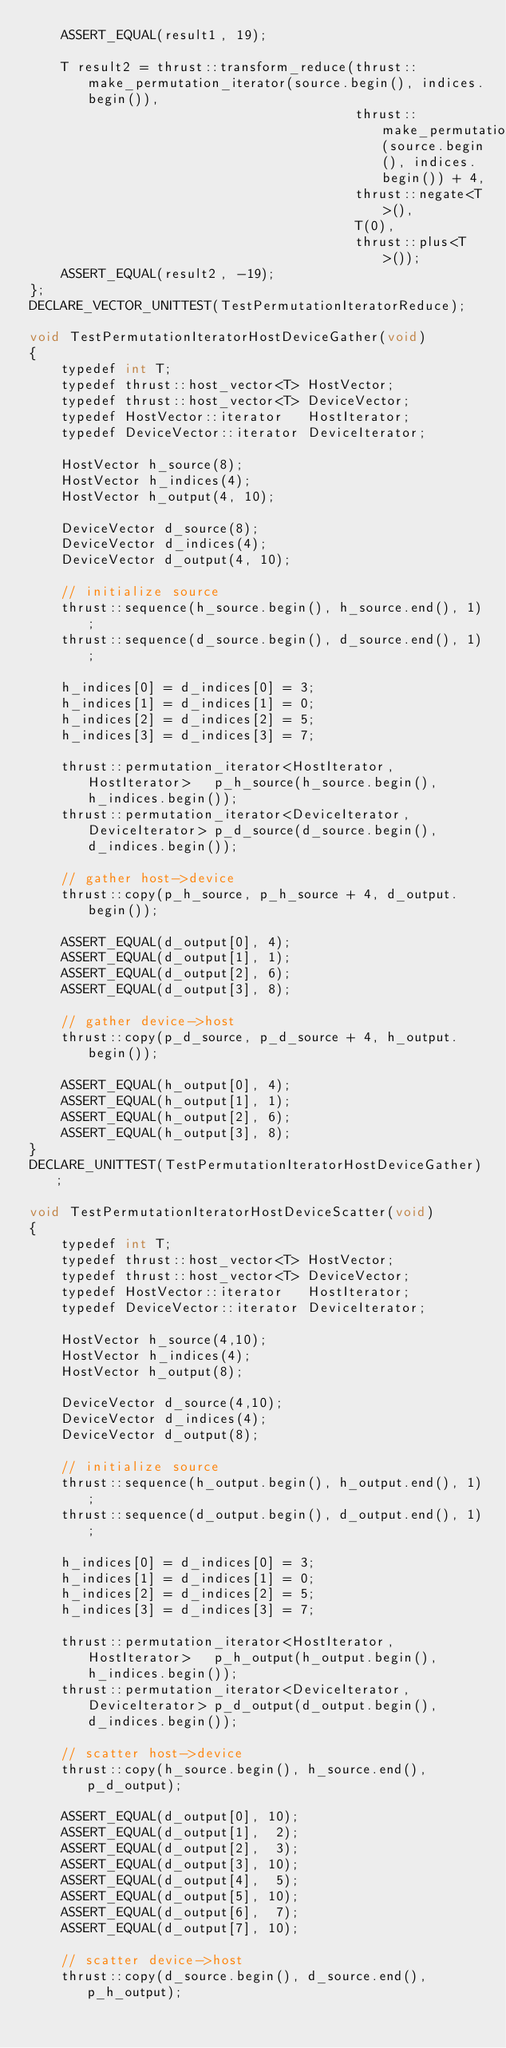Convert code to text. <code><loc_0><loc_0><loc_500><loc_500><_Cuda_>    ASSERT_EQUAL(result1, 19);
    
    T result2 = thrust::transform_reduce(thrust::make_permutation_iterator(source.begin(), indices.begin()),
                                         thrust::make_permutation_iterator(source.begin(), indices.begin()) + 4,
                                         thrust::negate<T>(),
                                         T(0),
                                         thrust::plus<T>());
    ASSERT_EQUAL(result2, -19);
};
DECLARE_VECTOR_UNITTEST(TestPermutationIteratorReduce);

void TestPermutationIteratorHostDeviceGather(void)
{
    typedef int T;
    typedef thrust::host_vector<T> HostVector;
    typedef thrust::host_vector<T> DeviceVector;
    typedef HostVector::iterator   HostIterator;
    typedef DeviceVector::iterator DeviceIterator;

    HostVector h_source(8);
    HostVector h_indices(4);
    HostVector h_output(4, 10);
    
    DeviceVector d_source(8);
    DeviceVector d_indices(4);
    DeviceVector d_output(4, 10);

    // initialize source
    thrust::sequence(h_source.begin(), h_source.end(), 1);
    thrust::sequence(d_source.begin(), d_source.end(), 1);

    h_indices[0] = d_indices[0] = 3;
    h_indices[1] = d_indices[1] = 0;
    h_indices[2] = d_indices[2] = 5;
    h_indices[3] = d_indices[3] = 7;
   
    thrust::permutation_iterator<HostIterator,   HostIterator>   p_h_source(h_source.begin(), h_indices.begin());
    thrust::permutation_iterator<DeviceIterator, DeviceIterator> p_d_source(d_source.begin(), d_indices.begin());

    // gather host->device
    thrust::copy(p_h_source, p_h_source + 4, d_output.begin());

    ASSERT_EQUAL(d_output[0], 4);
    ASSERT_EQUAL(d_output[1], 1);
    ASSERT_EQUAL(d_output[2], 6);
    ASSERT_EQUAL(d_output[3], 8);
    
    // gather device->host
    thrust::copy(p_d_source, p_d_source + 4, h_output.begin());

    ASSERT_EQUAL(h_output[0], 4);
    ASSERT_EQUAL(h_output[1], 1);
    ASSERT_EQUAL(h_output[2], 6);
    ASSERT_EQUAL(h_output[3], 8);
}
DECLARE_UNITTEST(TestPermutationIteratorHostDeviceGather);

void TestPermutationIteratorHostDeviceScatter(void)
{
    typedef int T;
    typedef thrust::host_vector<T> HostVector;
    typedef thrust::host_vector<T> DeviceVector;
    typedef HostVector::iterator   HostIterator;
    typedef DeviceVector::iterator DeviceIterator;

    HostVector h_source(4,10);
    HostVector h_indices(4);
    HostVector h_output(8);
    
    DeviceVector d_source(4,10);
    DeviceVector d_indices(4);
    DeviceVector d_output(8);

    // initialize source
    thrust::sequence(h_output.begin(), h_output.end(), 1);
    thrust::sequence(d_output.begin(), d_output.end(), 1);

    h_indices[0] = d_indices[0] = 3;
    h_indices[1] = d_indices[1] = 0;
    h_indices[2] = d_indices[2] = 5;
    h_indices[3] = d_indices[3] = 7;
   
    thrust::permutation_iterator<HostIterator,   HostIterator>   p_h_output(h_output.begin(), h_indices.begin());
    thrust::permutation_iterator<DeviceIterator, DeviceIterator> p_d_output(d_output.begin(), d_indices.begin());

    // scatter host->device
    thrust::copy(h_source.begin(), h_source.end(), p_d_output);

    ASSERT_EQUAL(d_output[0], 10);
    ASSERT_EQUAL(d_output[1],  2);
    ASSERT_EQUAL(d_output[2],  3);
    ASSERT_EQUAL(d_output[3], 10);
    ASSERT_EQUAL(d_output[4],  5);
    ASSERT_EQUAL(d_output[5], 10);
    ASSERT_EQUAL(d_output[6],  7);
    ASSERT_EQUAL(d_output[7], 10);
    
    // scatter device->host
    thrust::copy(d_source.begin(), d_source.end(), p_h_output);
</code> 